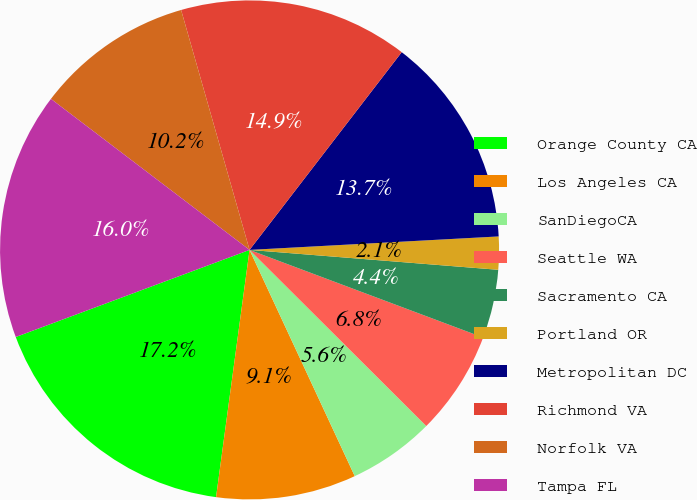Convert chart. <chart><loc_0><loc_0><loc_500><loc_500><pie_chart><fcel>Orange County CA<fcel>Los Angeles CA<fcel>SanDiegoCA<fcel>Seattle WA<fcel>Sacramento CA<fcel>Portland OR<fcel>Metropolitan DC<fcel>Richmond VA<fcel>Norfolk VA<fcel>Tampa FL<nl><fcel>17.18%<fcel>9.07%<fcel>5.6%<fcel>6.76%<fcel>4.44%<fcel>2.13%<fcel>13.7%<fcel>14.86%<fcel>10.23%<fcel>16.02%<nl></chart> 